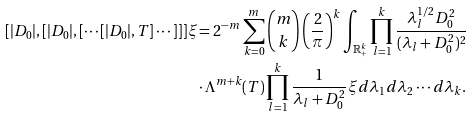Convert formula to latex. <formula><loc_0><loc_0><loc_500><loc_500>[ | D _ { 0 } | , [ | D _ { 0 } | , [ \cdots [ | D _ { 0 } | , T ] \cdots ] ] ] \xi & = 2 ^ { - m } \sum _ { k = 0 } ^ { m } \binom { m } { k } \left ( \frac { 2 } { \pi } \right ) ^ { k } \int _ { \mathbb { R } ^ { k } _ { + } } \prod _ { l = 1 } ^ { k } \frac { \lambda _ { l } ^ { 1 / 2 } D _ { 0 } ^ { 2 } } { ( \lambda _ { l } + D _ { 0 } ^ { 2 } ) ^ { 2 } } \\ & \cdot \Lambda ^ { m + k } ( T ) \prod _ { l = 1 } ^ { k } \frac { 1 } { \lambda _ { l } + D _ { 0 } ^ { 2 } } \xi d \lambda _ { 1 } d \lambda _ { 2 } \cdots d \lambda _ { k } .</formula> 